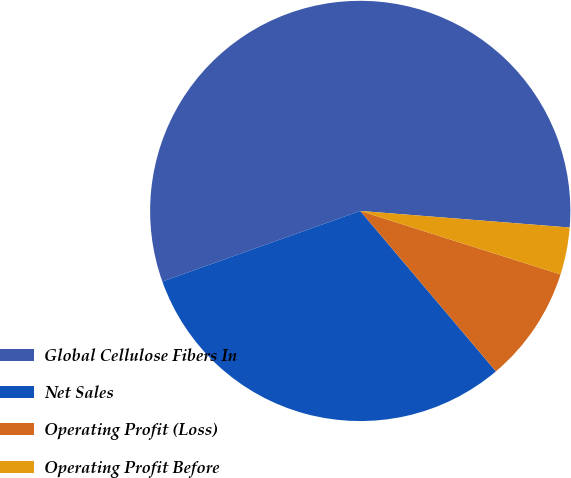Convert chart. <chart><loc_0><loc_0><loc_500><loc_500><pie_chart><fcel>Global Cellulose Fibers In<fcel>Net Sales<fcel>Operating Profit (Loss)<fcel>Operating Profit Before<nl><fcel>56.71%<fcel>30.72%<fcel>8.94%<fcel>3.63%<nl></chart> 